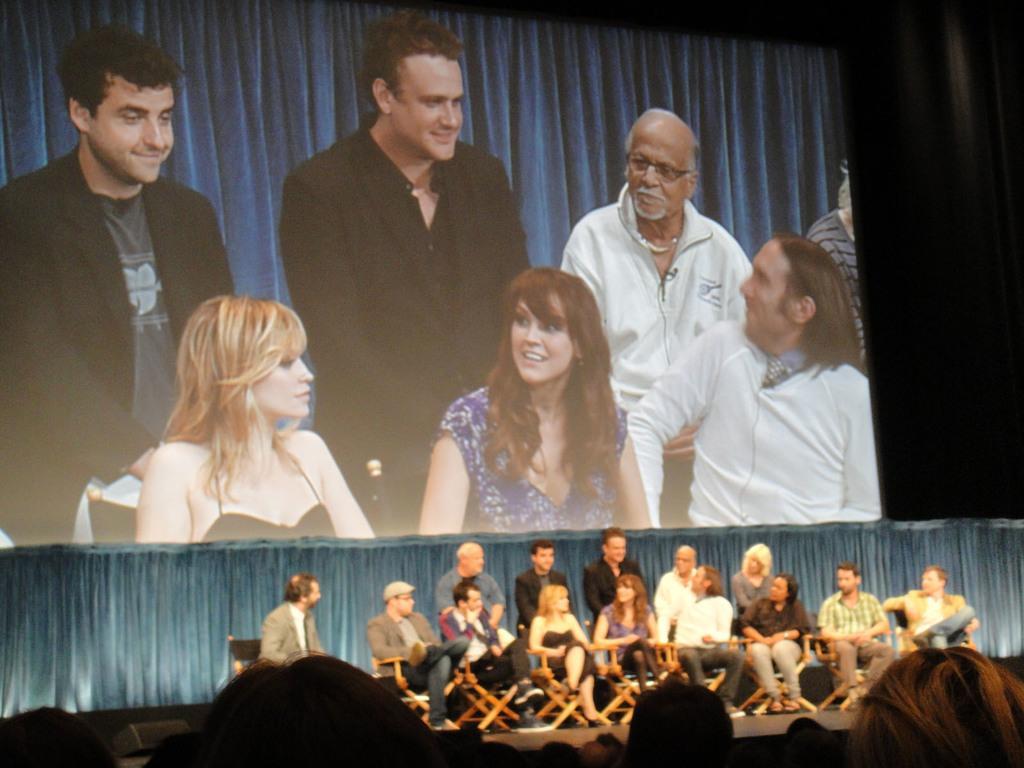How would you summarize this image in a sentence or two? In this picture I can see few people sitting on the chairs and few people standing in the back and I can see curtains. I can see few audience at the bottom of the picture and a screen at the top. 